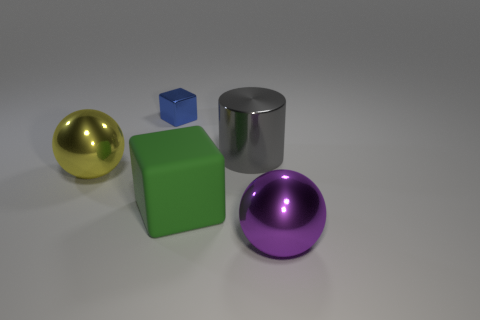Add 1 green blocks. How many objects exist? 6 Subtract all cylinders. How many objects are left? 4 Subtract all big green rubber objects. Subtract all large yellow objects. How many objects are left? 3 Add 2 purple metallic objects. How many purple metallic objects are left? 3 Add 2 tiny gray things. How many tiny gray things exist? 2 Subtract 0 brown blocks. How many objects are left? 5 